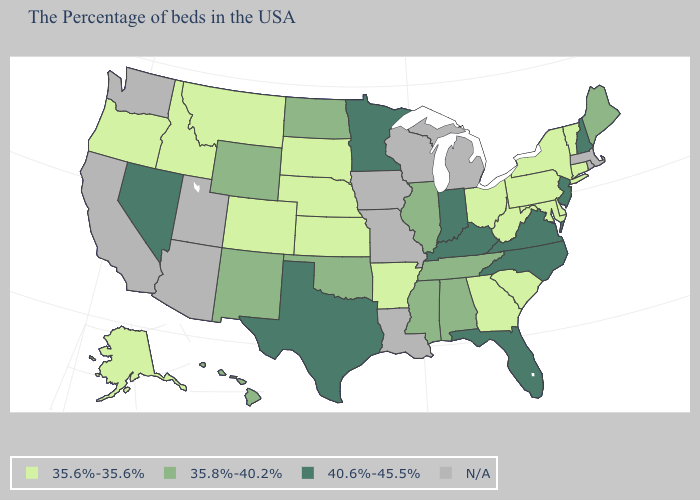Does South Dakota have the lowest value in the USA?
Keep it brief. Yes. Name the states that have a value in the range 35.6%-35.6%?
Keep it brief. Vermont, Connecticut, New York, Delaware, Maryland, Pennsylvania, South Carolina, West Virginia, Ohio, Georgia, Arkansas, Kansas, Nebraska, South Dakota, Colorado, Montana, Idaho, Oregon, Alaska. What is the value of Maryland?
Give a very brief answer. 35.6%-35.6%. What is the value of Maryland?
Keep it brief. 35.6%-35.6%. How many symbols are there in the legend?
Be succinct. 4. Name the states that have a value in the range N/A?
Short answer required. Massachusetts, Rhode Island, Michigan, Wisconsin, Louisiana, Missouri, Iowa, Utah, Arizona, California, Washington. How many symbols are there in the legend?
Answer briefly. 4. Name the states that have a value in the range 40.6%-45.5%?
Be succinct. New Hampshire, New Jersey, Virginia, North Carolina, Florida, Kentucky, Indiana, Minnesota, Texas, Nevada. Name the states that have a value in the range 35.8%-40.2%?
Keep it brief. Maine, Alabama, Tennessee, Illinois, Mississippi, Oklahoma, North Dakota, Wyoming, New Mexico, Hawaii. What is the value of North Dakota?
Concise answer only. 35.8%-40.2%. Which states hav the highest value in the MidWest?
Short answer required. Indiana, Minnesota. Does Arkansas have the highest value in the South?
Answer briefly. No. What is the lowest value in the USA?
Give a very brief answer. 35.6%-35.6%. 